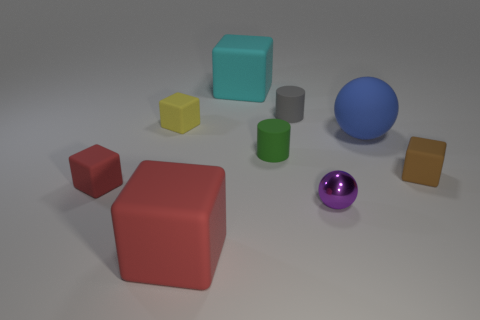There is a object that is left of the small green object and in front of the small red cube; what shape is it?
Provide a succinct answer. Cube. What is the material of the cyan cube?
Provide a short and direct response. Rubber. What number of balls are either red matte objects or small brown rubber objects?
Provide a succinct answer. 0. Do the green object and the small red object have the same material?
Provide a succinct answer. Yes. There is a brown thing that is the same shape as the large cyan rubber object; what size is it?
Offer a terse response. Small. What is the material of the small thing that is to the left of the tiny gray object and on the right side of the yellow block?
Keep it short and to the point. Rubber. Are there an equal number of gray matte things in front of the big sphere and tiny yellow rubber objects?
Ensure brevity in your answer.  No. What number of objects are big matte cubes in front of the small green rubber object or yellow matte things?
Provide a short and direct response. 2. Do the ball behind the small green cylinder and the metal object have the same color?
Make the answer very short. No. How big is the rubber cube on the right side of the large cyan object?
Keep it short and to the point. Small. 